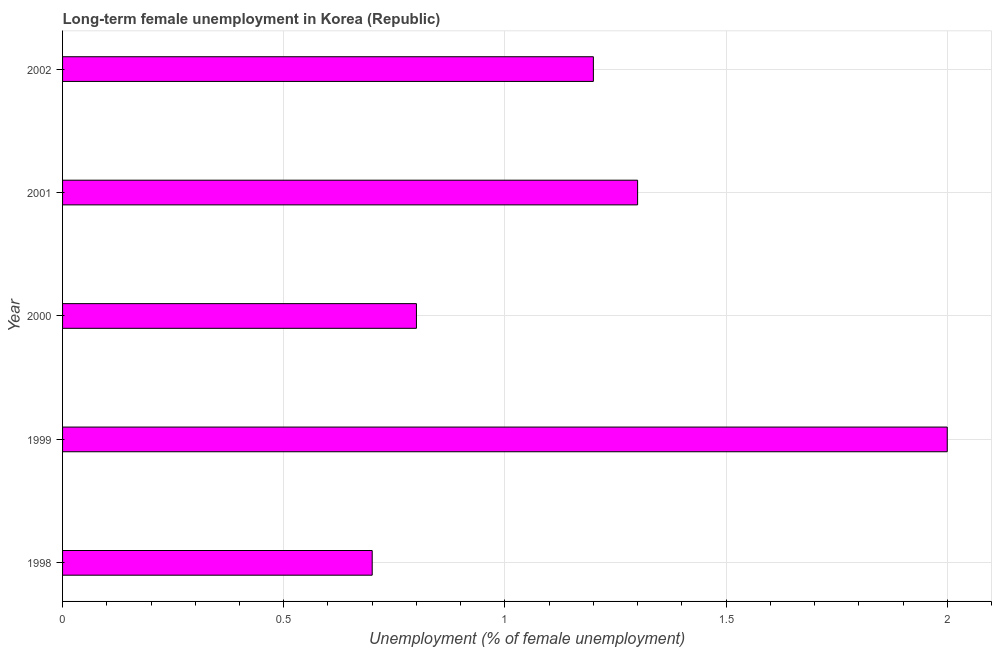What is the title of the graph?
Offer a very short reply. Long-term female unemployment in Korea (Republic). What is the label or title of the X-axis?
Ensure brevity in your answer.  Unemployment (% of female unemployment). What is the label or title of the Y-axis?
Your response must be concise. Year. What is the long-term female unemployment in 2000?
Your answer should be compact. 0.8. Across all years, what is the minimum long-term female unemployment?
Offer a terse response. 0.7. In which year was the long-term female unemployment maximum?
Your answer should be compact. 1999. In which year was the long-term female unemployment minimum?
Make the answer very short. 1998. What is the sum of the long-term female unemployment?
Your response must be concise. 6. What is the difference between the long-term female unemployment in 1999 and 2001?
Your answer should be very brief. 0.7. What is the median long-term female unemployment?
Your answer should be very brief. 1.2. What is the ratio of the long-term female unemployment in 2000 to that in 2001?
Your response must be concise. 0.61. Is the difference between the long-term female unemployment in 1998 and 1999 greater than the difference between any two years?
Your response must be concise. Yes. What is the difference between the highest and the second highest long-term female unemployment?
Provide a short and direct response. 0.7. How many bars are there?
Your answer should be compact. 5. What is the Unemployment (% of female unemployment) of 1998?
Offer a terse response. 0.7. What is the Unemployment (% of female unemployment) of 2000?
Provide a short and direct response. 0.8. What is the Unemployment (% of female unemployment) in 2001?
Offer a very short reply. 1.3. What is the Unemployment (% of female unemployment) in 2002?
Your response must be concise. 1.2. What is the difference between the Unemployment (% of female unemployment) in 1998 and 1999?
Your answer should be compact. -1.3. What is the difference between the Unemployment (% of female unemployment) in 1998 and 2000?
Keep it short and to the point. -0.1. What is the difference between the Unemployment (% of female unemployment) in 1998 and 2002?
Make the answer very short. -0.5. What is the difference between the Unemployment (% of female unemployment) in 1999 and 2002?
Your response must be concise. 0.8. What is the difference between the Unemployment (% of female unemployment) in 2000 and 2002?
Offer a very short reply. -0.4. What is the ratio of the Unemployment (% of female unemployment) in 1998 to that in 1999?
Keep it short and to the point. 0.35. What is the ratio of the Unemployment (% of female unemployment) in 1998 to that in 2001?
Keep it short and to the point. 0.54. What is the ratio of the Unemployment (% of female unemployment) in 1998 to that in 2002?
Offer a very short reply. 0.58. What is the ratio of the Unemployment (% of female unemployment) in 1999 to that in 2000?
Your response must be concise. 2.5. What is the ratio of the Unemployment (% of female unemployment) in 1999 to that in 2001?
Offer a terse response. 1.54. What is the ratio of the Unemployment (% of female unemployment) in 1999 to that in 2002?
Offer a terse response. 1.67. What is the ratio of the Unemployment (% of female unemployment) in 2000 to that in 2001?
Keep it short and to the point. 0.61. What is the ratio of the Unemployment (% of female unemployment) in 2000 to that in 2002?
Offer a terse response. 0.67. What is the ratio of the Unemployment (% of female unemployment) in 2001 to that in 2002?
Offer a very short reply. 1.08. 